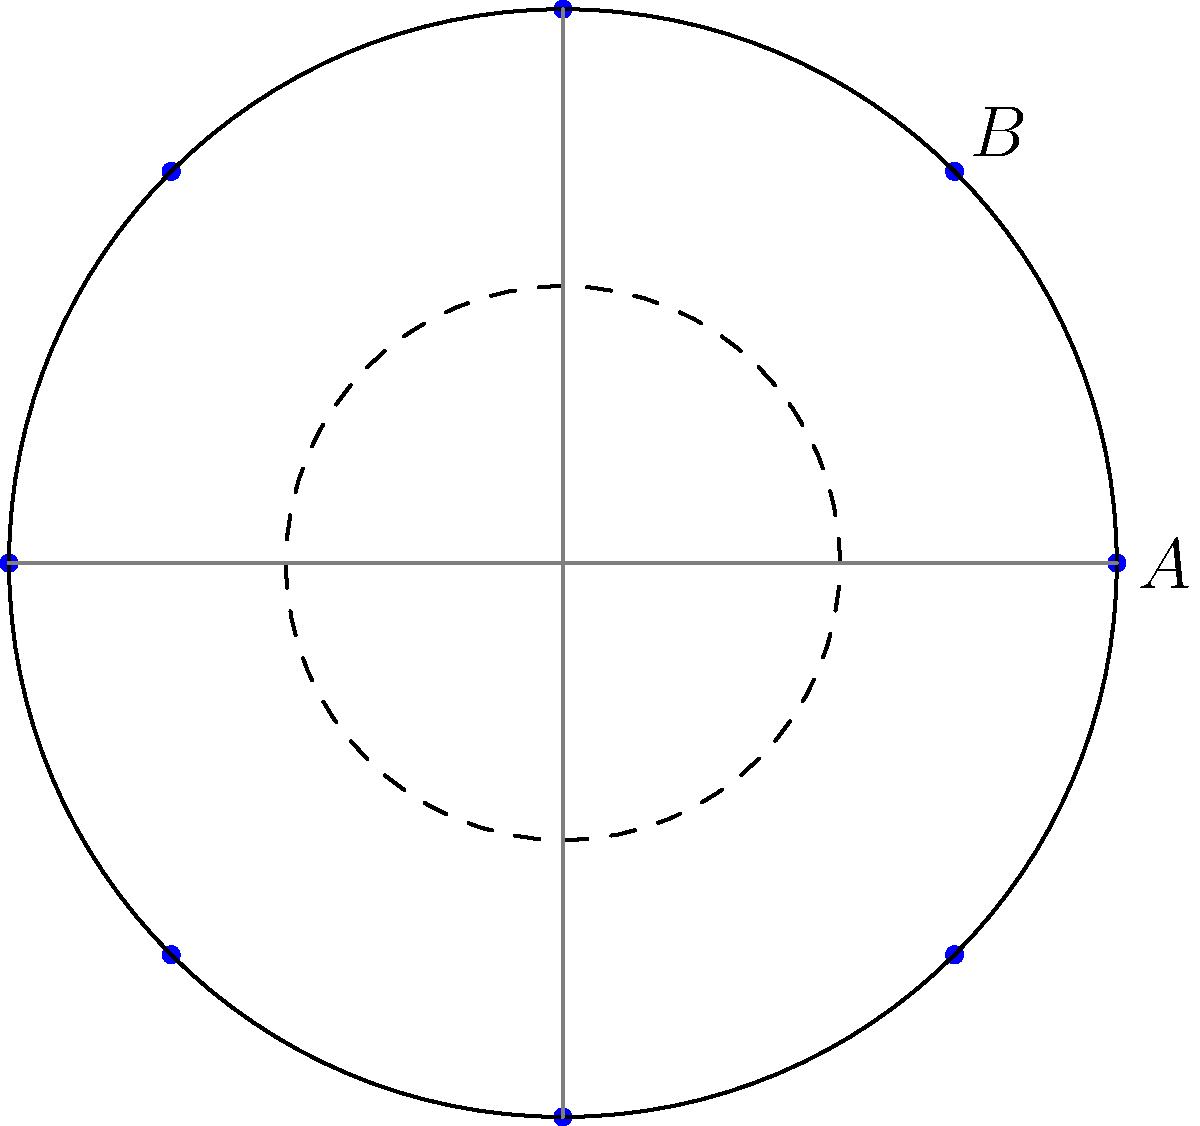For a royal banquet, you are tasked with arranging 8 identical circular plates on a large round table. The plates are to be placed equidistantly along the circumference of the table. If the angle between two adjacent plates is $\frac{\pi}{4}$ radians, what is the polar coordinate of plate B in terms of $r$, where $r$ is the radius of the table? To solve this problem, let's follow these steps:

1) First, we need to understand that the plates are arranged in a circular pattern with radial symmetry. The center of the table is the origin (0,0) in our polar coordinate system.

2) We are given that there are 8 plates, which means they are spaced at intervals of $\frac{2\pi}{8} = \frac{\pi}{4}$ radians.

3) In the diagram, plate A is positioned at (r, 0) in polar coordinates, which corresponds to an angle of 0 radians.

4) Plate B is the next plate clockwise from A. Since the angle between adjacent plates is $\frac{\pi}{4}$, the angle for plate B is also $\frac{\pi}{4}$.

5) In polar coordinates, a point is represented as (r, θ), where r is the distance from the origin and θ is the angle from the positive x-axis.

6) For plate B, we already know that θ = $\frac{\pi}{4}$, and the distance from the center is r (the radius of the table).

7) Therefore, the polar coordinate of plate B is $(r, \frac{\pi}{4})$.
Answer: $(r, \frac{\pi}{4})$ 